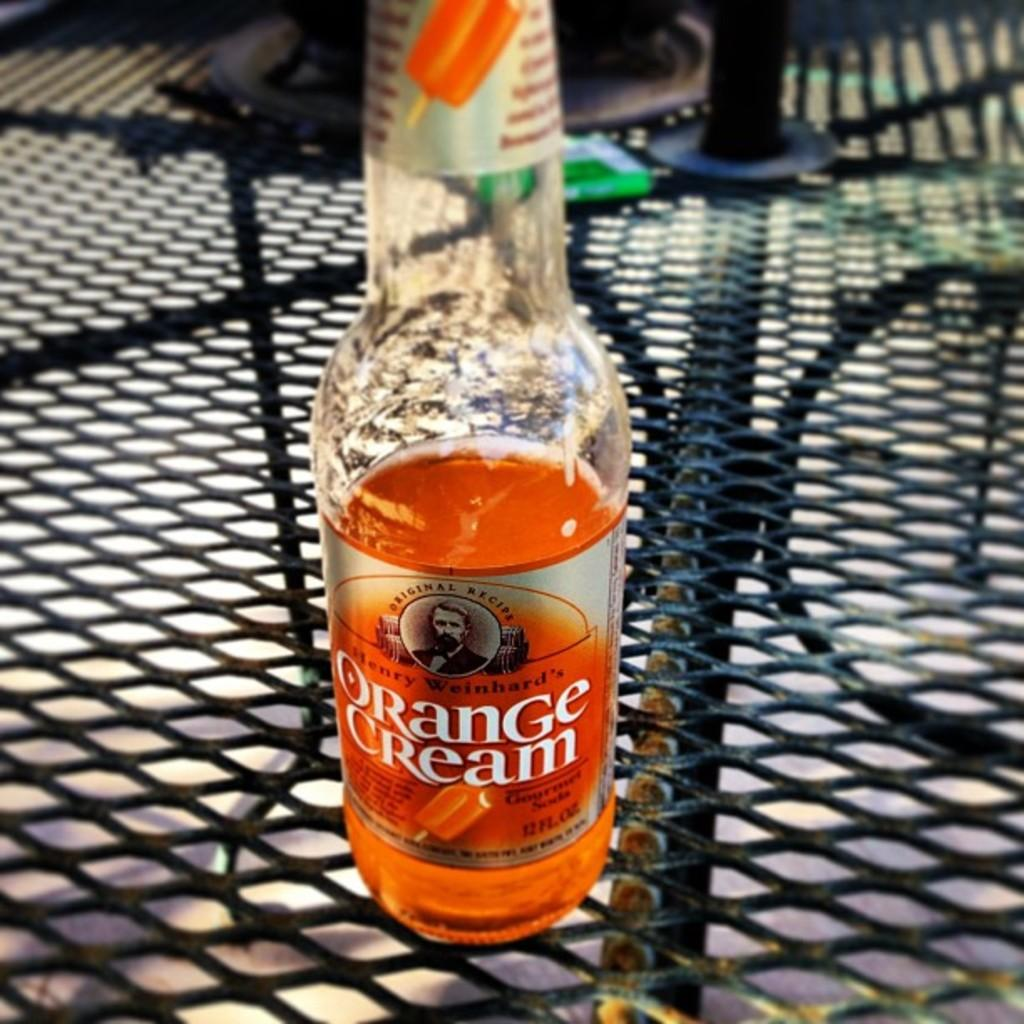<image>
Render a clear and concise summary of the photo. A bottle of Orange Cream rests on a table. 